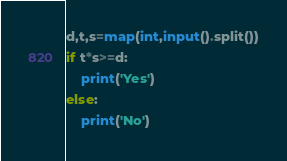<code> <loc_0><loc_0><loc_500><loc_500><_Python_>d,t,s=map(int,input().split())
if t*s>=d:
    print('Yes')
else:
    print('No')</code> 